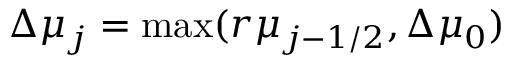<formula> <loc_0><loc_0><loc_500><loc_500>\Delta \mu _ { j } = \max ( r \mu _ { j - 1 / 2 } , \Delta \mu _ { 0 } )</formula> 